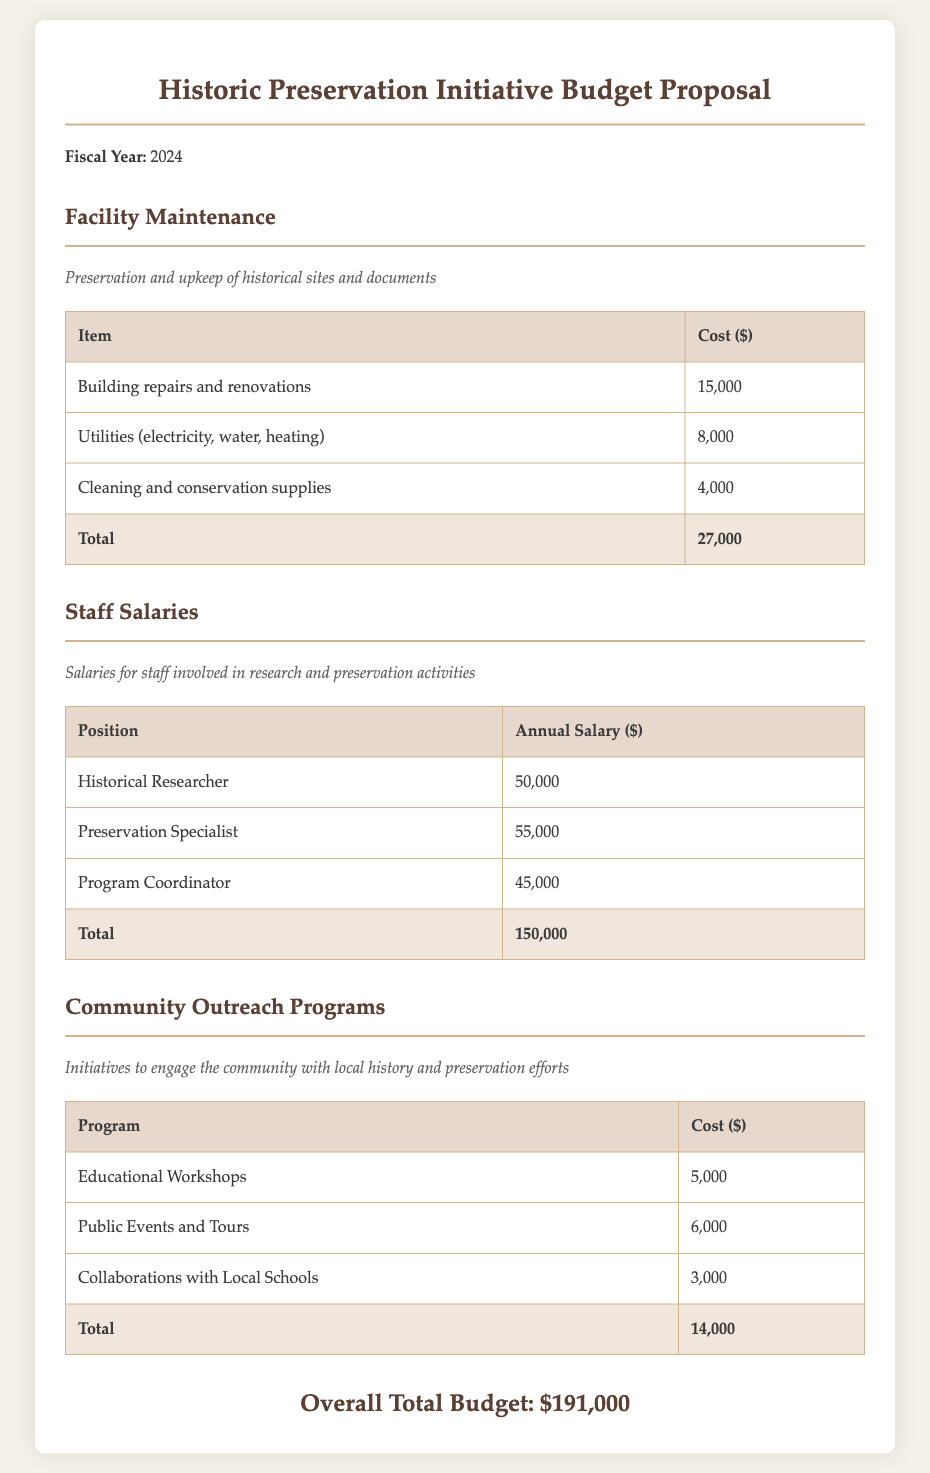What is the fiscal year for the budget proposal? The fiscal year specified in the document is for the year 2024.
Answer: 2024 What is the total cost for facility maintenance? The total cost for facility maintenance is calculated from the various item expenses listed in that section, which totals to $27,000.
Answer: $27,000 What is the annual salary of the Preservation Specialist? The document lists the annual salary of the Preservation Specialist, which is $55,000.
Answer: $55,000 How much is allocated for educational workshops? The document provides the cost allocated for educational workshops under community outreach programs, which is $5,000.
Answer: $5,000 What is the overall total budget? The overall total budget is derived from the summation of all sections, which is detailed in the document as $191,000.
Answer: $191,000 What is the sum of staff salaries? The total salaries for staff positions in the document are revealed to be $150,000, based on the listed salaries.
Answer: $150,000 What is the total cost for community outreach programs? The total for community outreach programs is the cumulative cost of various initiatives detailed, amounting to $14,000.
Answer: $14,000 What type of document is being presented? The document is specifically a budget proposal related to a historic preservation initiative.
Answer: Budget Proposal 